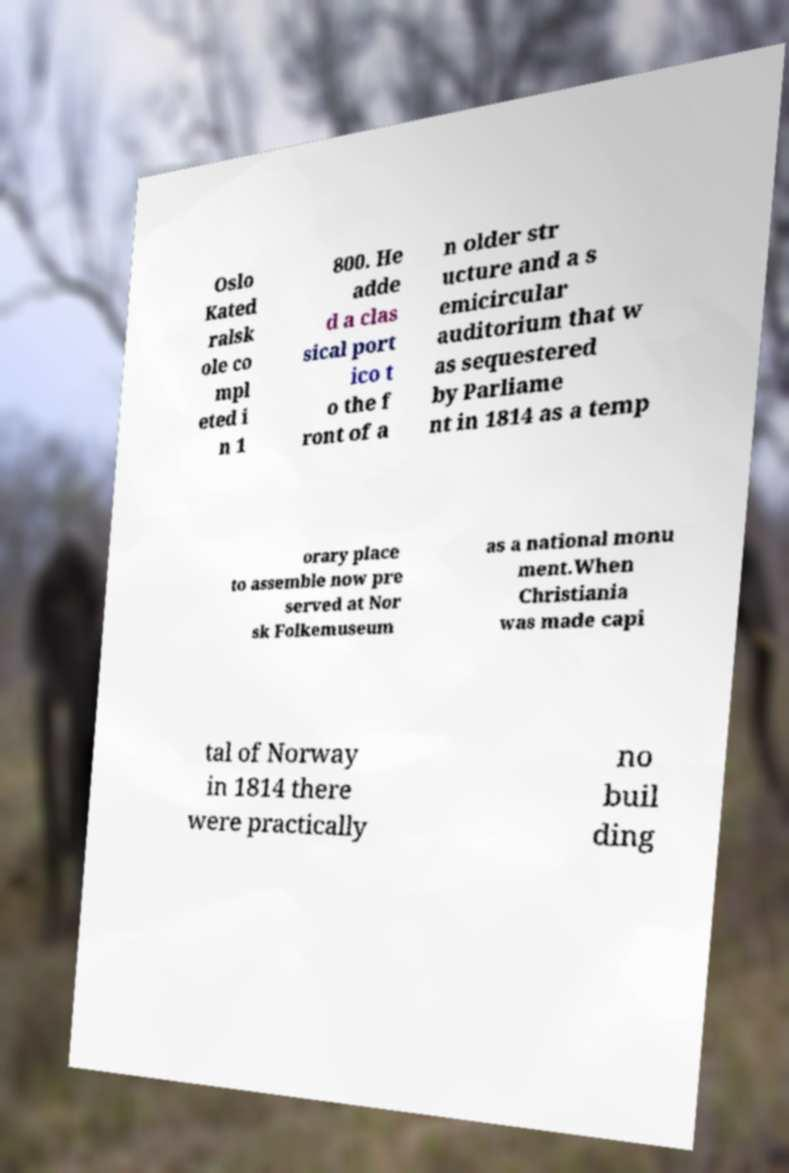I need the written content from this picture converted into text. Can you do that? Oslo Kated ralsk ole co mpl eted i n 1 800. He adde d a clas sical port ico t o the f ront of a n older str ucture and a s emicircular auditorium that w as sequestered by Parliame nt in 1814 as a temp orary place to assemble now pre served at Nor sk Folkemuseum as a national monu ment.When Christiania was made capi tal of Norway in 1814 there were practically no buil ding 